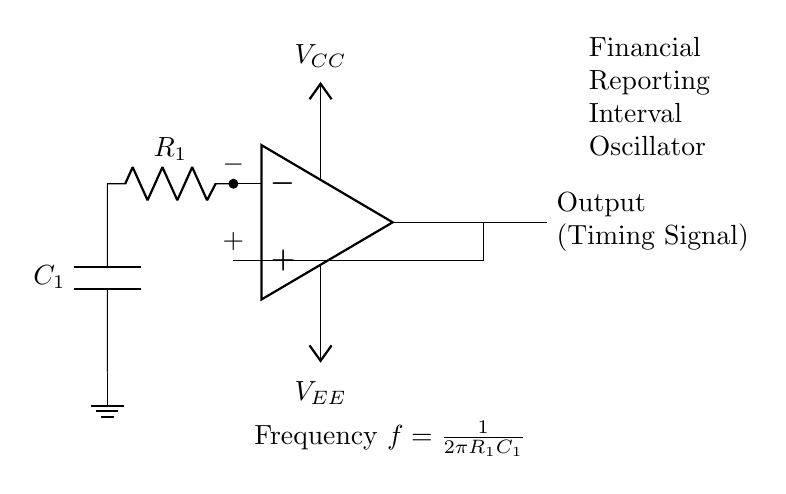What type of circuit is depicted? The circuit is an oscillator, specifically a simple timing signal oscillator, which is indicated by the configuration of the op-amp and the RC network.
Answer: Oscillator What are the two types of voltage supplies shown? The circuit includes a positive voltage supply denoted as V CC and a negative voltage supply denoted as V EE, which power the op-amp to function correctly.
Answer: V CC and V EE What components are used to create the timing function? The timing function is created using a resistor labeled R1 and a capacitor labeled C1 connected in an RC network, which forms the basis of the oscillator circuit.
Answer: R1 and C1 What is the formula for frequency in this circuit? The frequency formula is expressed as f equals one divided by two pi R1 C1, which indicates how frequency is directly related to the values of the resistor and capacitor in the circuit.
Answer: 1/2πR1C1 How does the feedback loop function in this circuit? The feedback loop in this circuit is created by connecting the output of the op-amp back to the inverting terminal, which is crucial for maintaining oscillations and ensuring the timing signal is generated.
Answer: Maintains oscillation What does the output of the circuit represent? The output of the circuit represents a timing signal, which is essential for determining the intervals for financial reporting, reflecting the regular oscillations produced by the circuit.
Answer: Timing Signal 